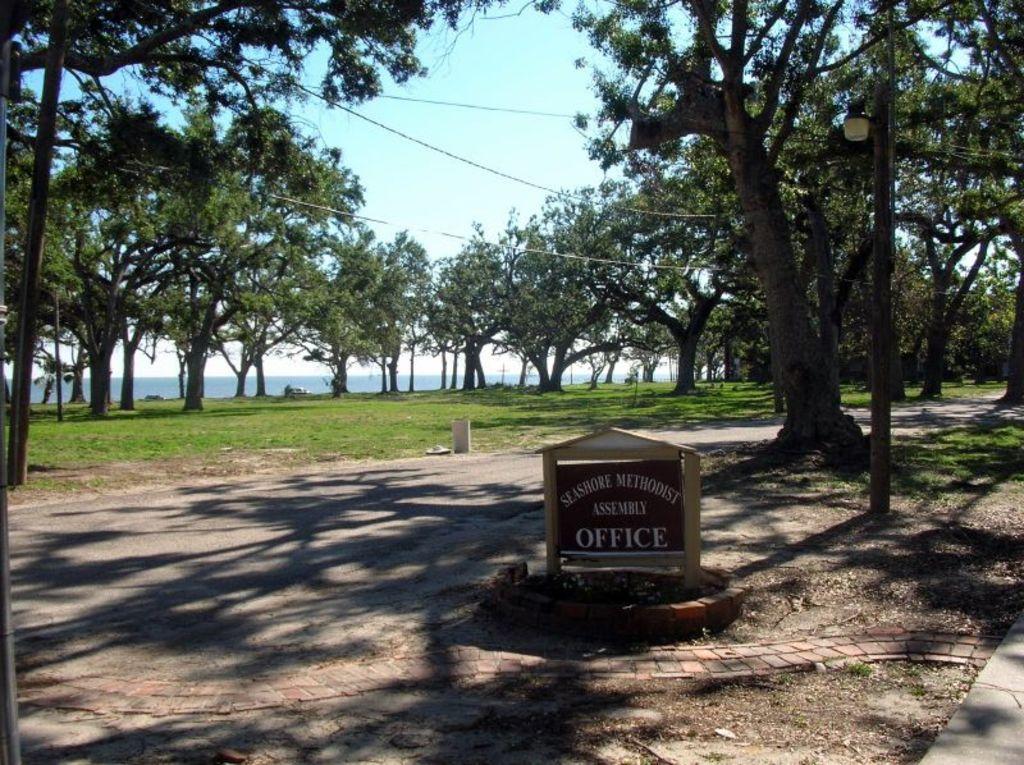Can you describe this image briefly? In the image there is a sign board with the name of the office and behind the sign board there are trees, grass and water surface. 